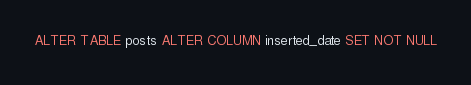<code> <loc_0><loc_0><loc_500><loc_500><_SQL_>ALTER TABLE posts ALTER COLUMN inserted_date SET NOT NULL</code> 